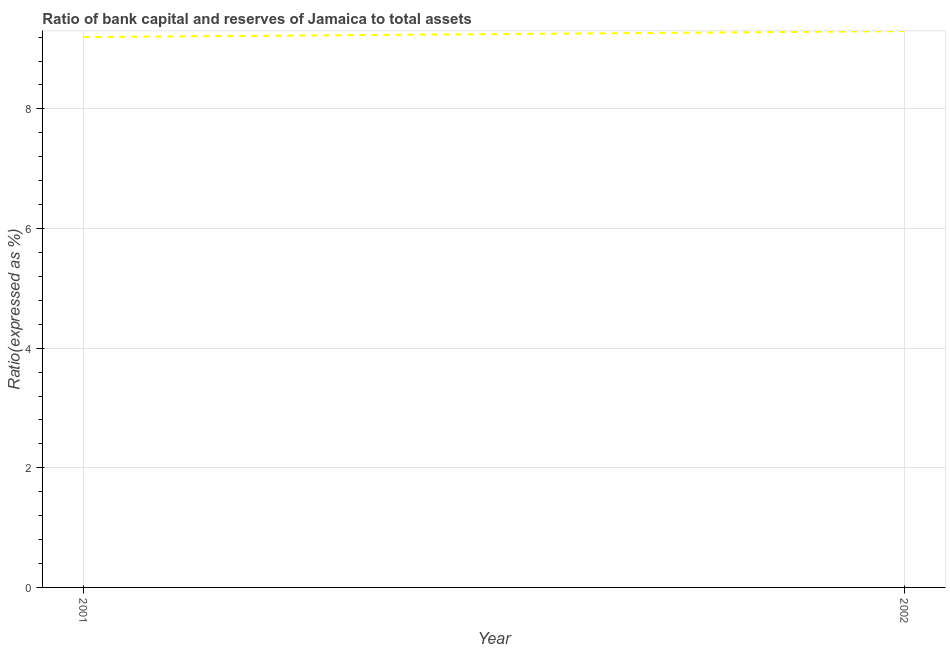What is the bank capital to assets ratio in 2001?
Make the answer very short. 9.2. Across all years, what is the minimum bank capital to assets ratio?
Provide a succinct answer. 9.2. In which year was the bank capital to assets ratio maximum?
Your answer should be very brief. 2002. What is the sum of the bank capital to assets ratio?
Offer a terse response. 18.5. What is the difference between the bank capital to assets ratio in 2001 and 2002?
Ensure brevity in your answer.  -0.1. What is the average bank capital to assets ratio per year?
Your answer should be compact. 9.25. What is the median bank capital to assets ratio?
Provide a short and direct response. 9.25. In how many years, is the bank capital to assets ratio greater than 7.2 %?
Ensure brevity in your answer.  2. Do a majority of the years between 2001 and 2002 (inclusive) have bank capital to assets ratio greater than 1.2000000000000002 %?
Your response must be concise. Yes. What is the ratio of the bank capital to assets ratio in 2001 to that in 2002?
Keep it short and to the point. 0.99. In how many years, is the bank capital to assets ratio greater than the average bank capital to assets ratio taken over all years?
Make the answer very short. 1. How many years are there in the graph?
Your answer should be very brief. 2. Does the graph contain any zero values?
Ensure brevity in your answer.  No. What is the title of the graph?
Ensure brevity in your answer.  Ratio of bank capital and reserves of Jamaica to total assets. What is the label or title of the X-axis?
Your answer should be compact. Year. What is the label or title of the Y-axis?
Your response must be concise. Ratio(expressed as %). What is the Ratio(expressed as %) of 2001?
Ensure brevity in your answer.  9.2. What is the Ratio(expressed as %) of 2002?
Your answer should be compact. 9.3. What is the difference between the Ratio(expressed as %) in 2001 and 2002?
Keep it short and to the point. -0.1. 